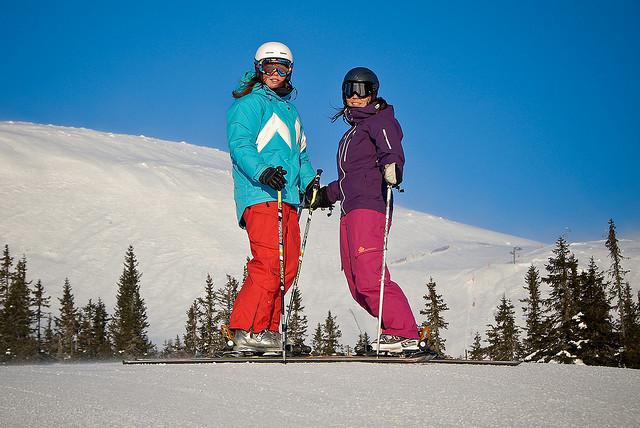What is she wearing to protect her eyes?
Concise answer only. Goggles. Is the snow deep?
Concise answer only. Yes. What color is the sky?
Answer briefly. Blue. How many people are in the photo?
Answer briefly. 2. What 4 colors make up 90 percent of the 2 females clothing?
Answer briefly. Blue, red, purple, pink. Is it cold out?
Write a very short answer. Yes. Are these kids trying to learn to ski?
Be succinct. Yes. What is the woman leaning on?
Write a very short answer. Ski poles. 